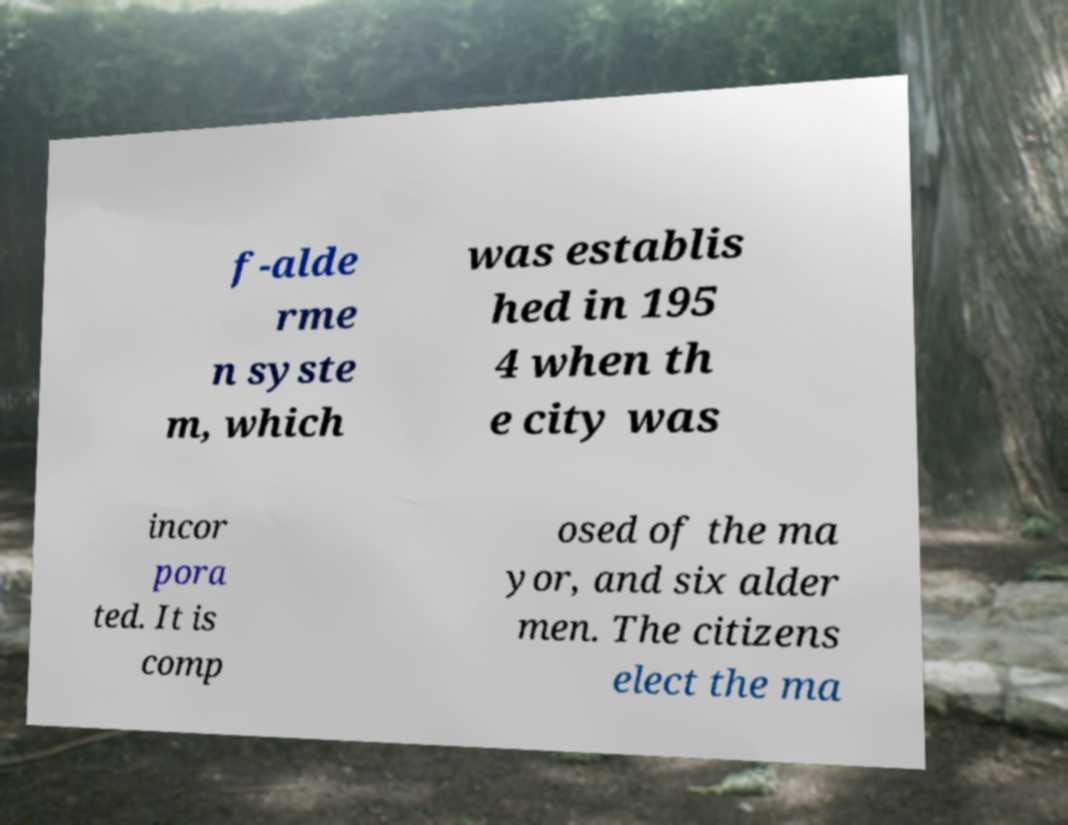What messages or text are displayed in this image? I need them in a readable, typed format. f-alde rme n syste m, which was establis hed in 195 4 when th e city was incor pora ted. It is comp osed of the ma yor, and six alder men. The citizens elect the ma 